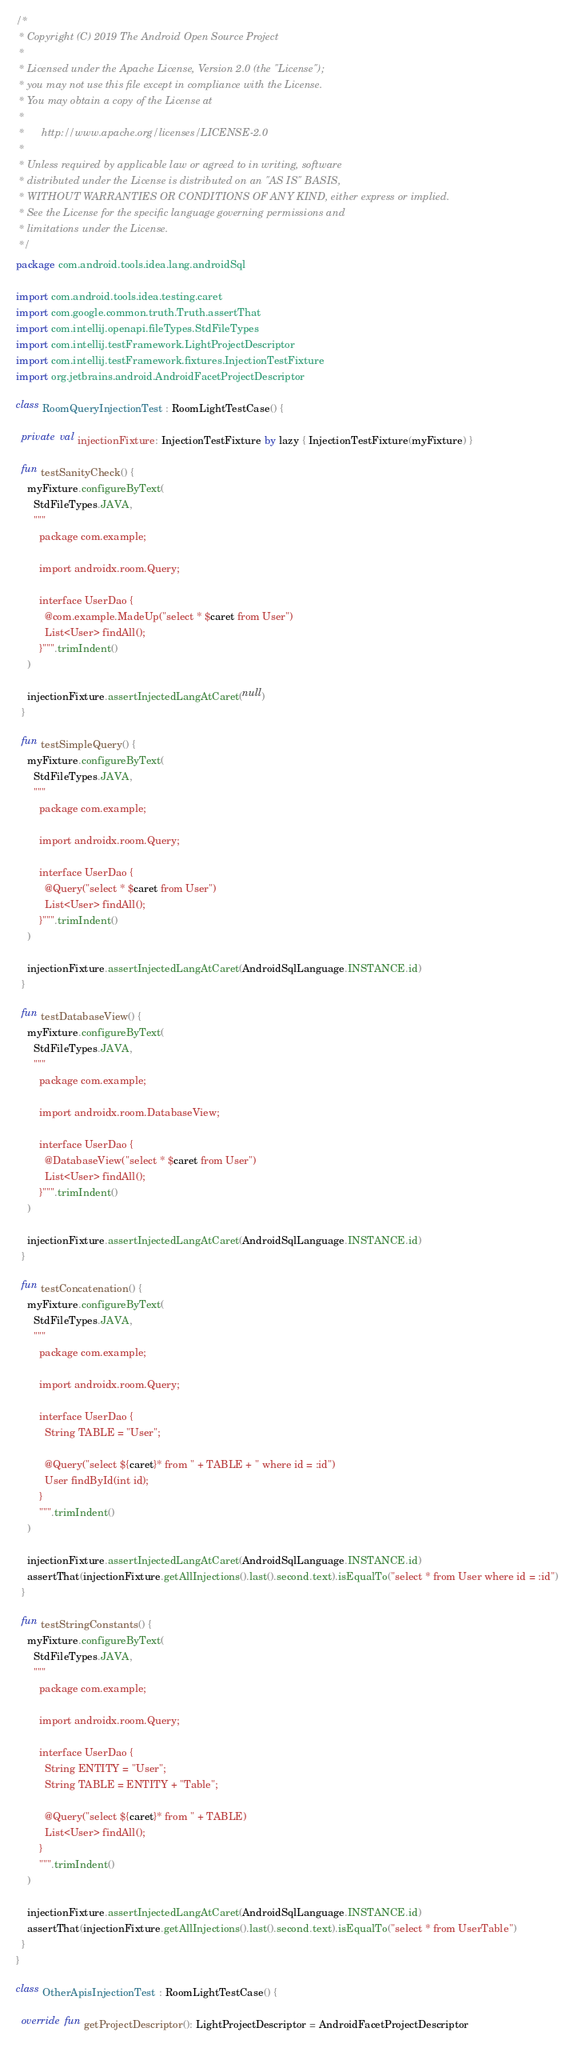Convert code to text. <code><loc_0><loc_0><loc_500><loc_500><_Kotlin_>/*
 * Copyright (C) 2019 The Android Open Source Project
 *
 * Licensed under the Apache License, Version 2.0 (the "License");
 * you may not use this file except in compliance with the License.
 * You may obtain a copy of the License at
 *
 *      http://www.apache.org/licenses/LICENSE-2.0
 *
 * Unless required by applicable law or agreed to in writing, software
 * distributed under the License is distributed on an "AS IS" BASIS,
 * WITHOUT WARRANTIES OR CONDITIONS OF ANY KIND, either express or implied.
 * See the License for the specific language governing permissions and
 * limitations under the License.
 */
package com.android.tools.idea.lang.androidSql

import com.android.tools.idea.testing.caret
import com.google.common.truth.Truth.assertThat
import com.intellij.openapi.fileTypes.StdFileTypes
import com.intellij.testFramework.LightProjectDescriptor
import com.intellij.testFramework.fixtures.InjectionTestFixture
import org.jetbrains.android.AndroidFacetProjectDescriptor

class RoomQueryInjectionTest : RoomLightTestCase() {

  private val injectionFixture: InjectionTestFixture by lazy { InjectionTestFixture(myFixture) }

  fun testSanityCheck() {
    myFixture.configureByText(
      StdFileTypes.JAVA,
      """
        package com.example;

        import androidx.room.Query;

        interface UserDao {
          @com.example.MadeUp("select * $caret from User")
          List<User> findAll();
        }""".trimIndent()
    )

    injectionFixture.assertInjectedLangAtCaret(null)
  }

  fun testSimpleQuery() {
    myFixture.configureByText(
      StdFileTypes.JAVA,
      """
        package com.example;

        import androidx.room.Query;

        interface UserDao {
          @Query("select * $caret from User")
          List<User> findAll();
        }""".trimIndent()
    )

    injectionFixture.assertInjectedLangAtCaret(AndroidSqlLanguage.INSTANCE.id)
  }

  fun testDatabaseView() {
    myFixture.configureByText(
      StdFileTypes.JAVA,
      """
        package com.example;

        import androidx.room.DatabaseView;

        interface UserDao {
          @DatabaseView("select * $caret from User")
          List<User> findAll();
        }""".trimIndent()
    )

    injectionFixture.assertInjectedLangAtCaret(AndroidSqlLanguage.INSTANCE.id)
  }

  fun testConcatenation() {
    myFixture.configureByText(
      StdFileTypes.JAVA,
      """
        package com.example;

        import androidx.room.Query;

        interface UserDao {
          String TABLE = "User";

          @Query("select ${caret}* from " + TABLE + " where id = :id")
          User findById(int id);
        }
        """.trimIndent()
    )

    injectionFixture.assertInjectedLangAtCaret(AndroidSqlLanguage.INSTANCE.id)
    assertThat(injectionFixture.getAllInjections().last().second.text).isEqualTo("select * from User where id = :id")
  }

  fun testStringConstants() {
    myFixture.configureByText(
      StdFileTypes.JAVA,
      """
        package com.example;

        import androidx.room.Query;

        interface UserDao {
          String ENTITY = "User";
          String TABLE = ENTITY + "Table";

          @Query("select ${caret}* from " + TABLE)
          List<User> findAll();
        }
        """.trimIndent()
    )

    injectionFixture.assertInjectedLangAtCaret(AndroidSqlLanguage.INSTANCE.id)
    assertThat(injectionFixture.getAllInjections().last().second.text).isEqualTo("select * from UserTable")
  }
}

class OtherApisInjectionTest : RoomLightTestCase() {

  override fun getProjectDescriptor(): LightProjectDescriptor = AndroidFacetProjectDescriptor
</code> 